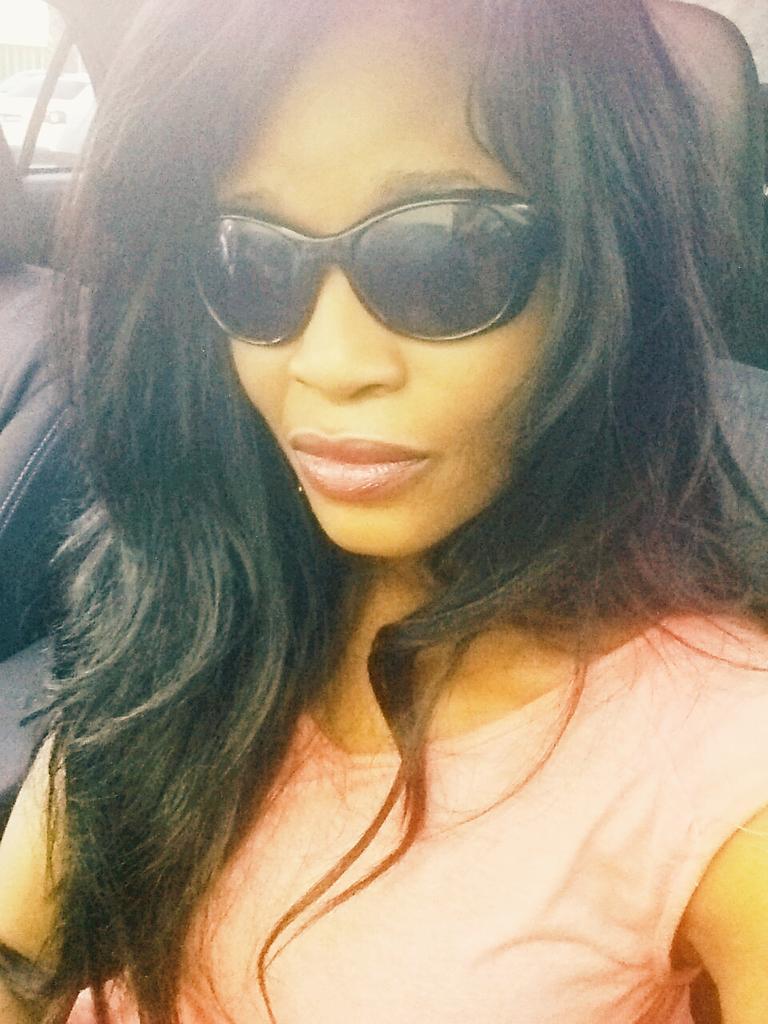In one or two sentences, can you explain what this image depicts? In this picture I can see there is a woman sitting inside the car and she is wearing goggles and a peach color shirt. There is a window in the backdrop. 